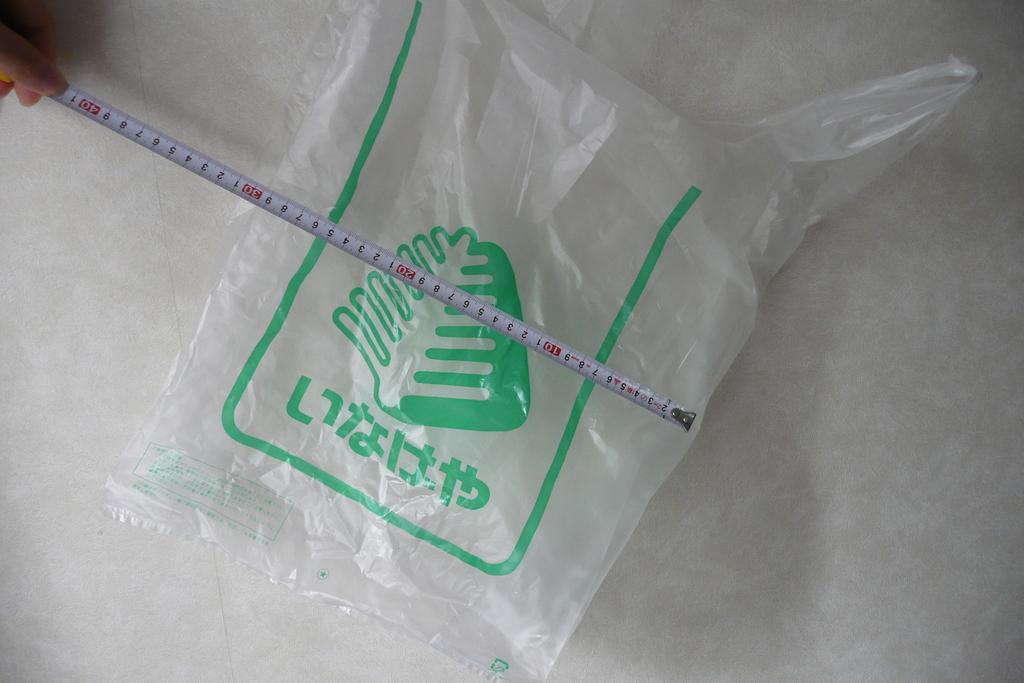Please provide a concise description of this image. In the image there is a cover on the floor with a measuring tape above it in a hand. 